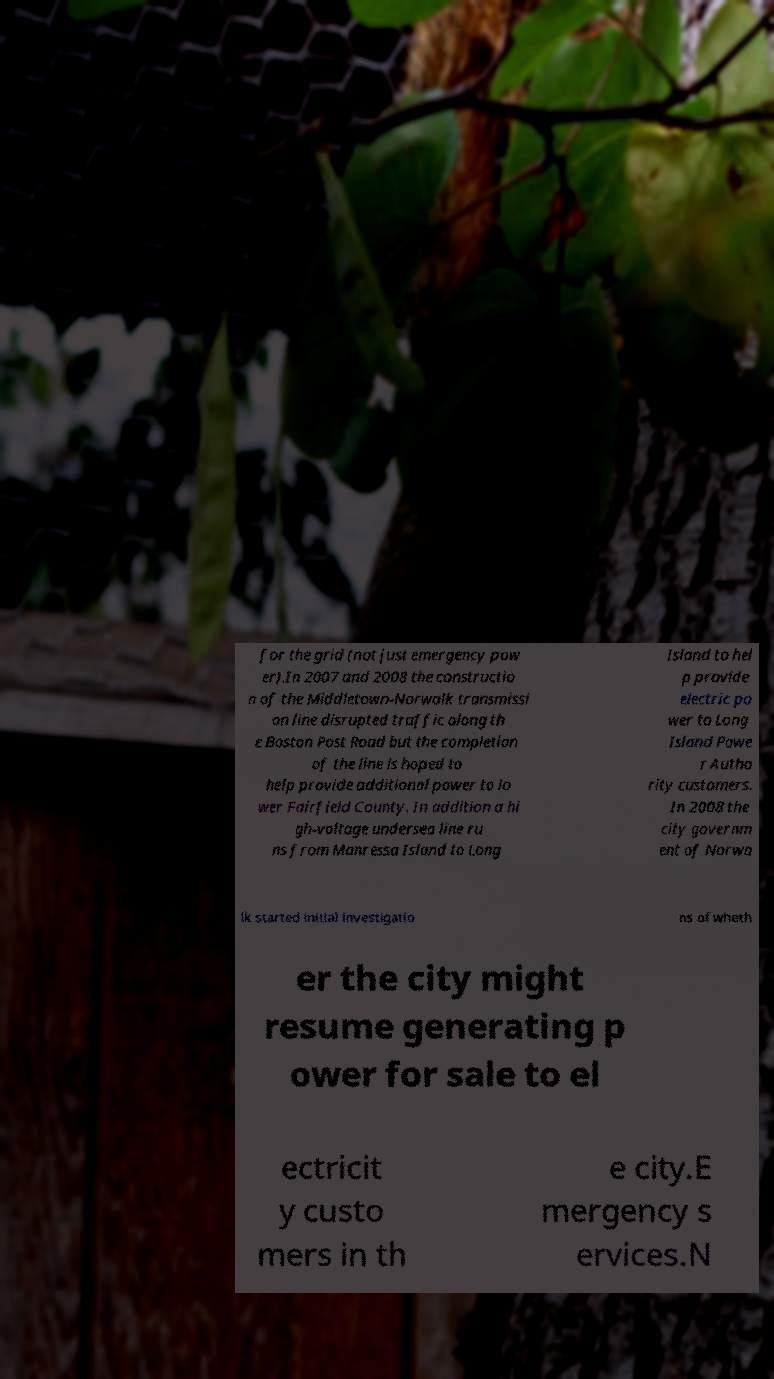For documentation purposes, I need the text within this image transcribed. Could you provide that? for the grid (not just emergency pow er).In 2007 and 2008 the constructio n of the Middletown-Norwalk transmissi on line disrupted traffic along th e Boston Post Road but the completion of the line is hoped to help provide additional power to lo wer Fairfield County. In addition a hi gh-voltage undersea line ru ns from Manressa Island to Long Island to hel p provide electric po wer to Long Island Powe r Autho rity customers. In 2008 the city governm ent of Norwa lk started initial investigatio ns of wheth er the city might resume generating p ower for sale to el ectricit y custo mers in th e city.E mergency s ervices.N 